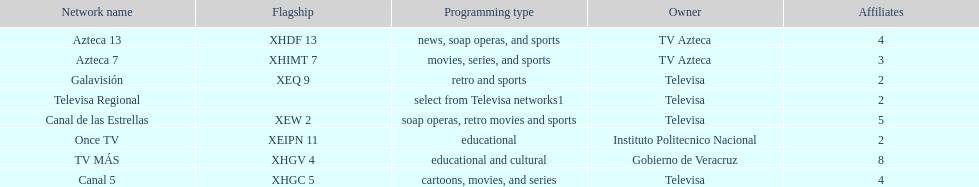Which is the only station with 8 affiliates? TV MÁS. 